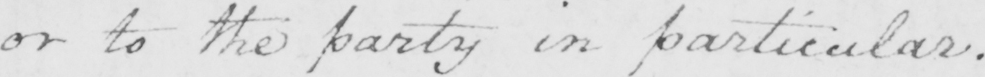Can you tell me what this handwritten text says? or to the party in particular . 